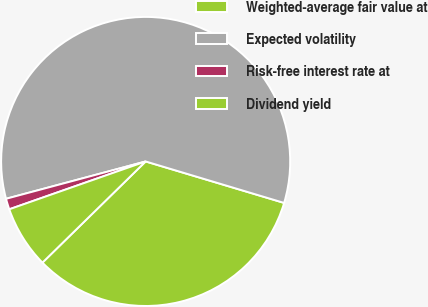<chart> <loc_0><loc_0><loc_500><loc_500><pie_chart><fcel>Weighted-average fair value at<fcel>Expected volatility<fcel>Risk-free interest rate at<fcel>Dividend yield<nl><fcel>33.03%<fcel>58.79%<fcel>1.21%<fcel>6.97%<nl></chart> 